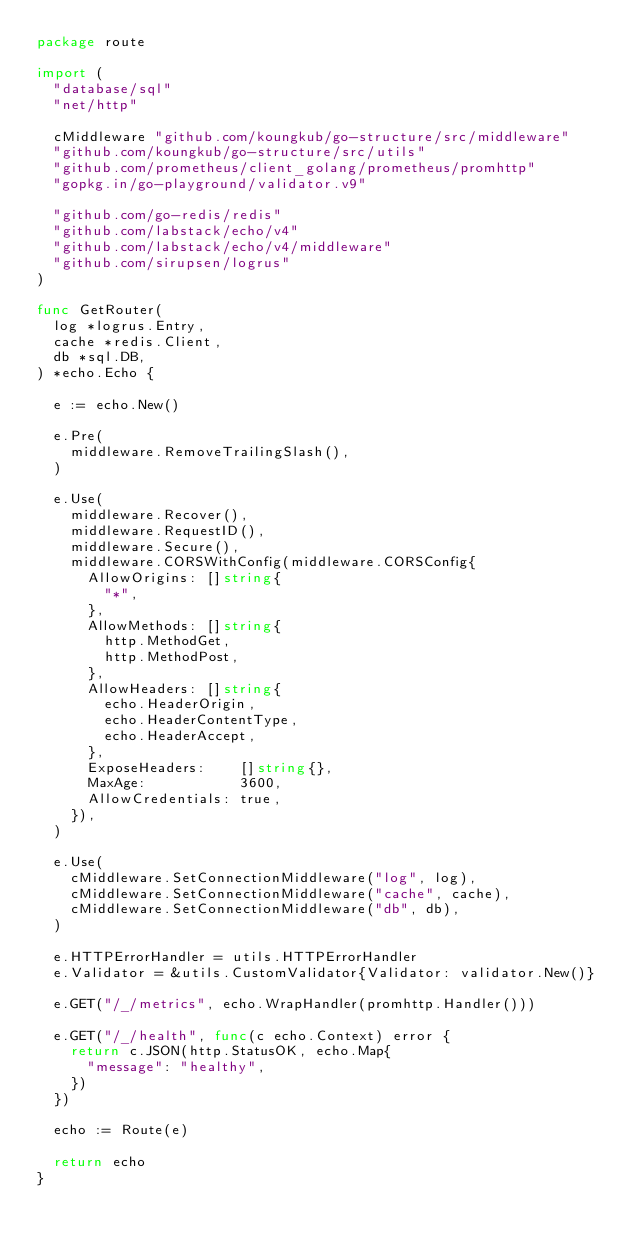Convert code to text. <code><loc_0><loc_0><loc_500><loc_500><_Go_>package route

import (
	"database/sql"
	"net/http"

	cMiddleware "github.com/koungkub/go-structure/src/middleware"
	"github.com/koungkub/go-structure/src/utils"
	"github.com/prometheus/client_golang/prometheus/promhttp"
	"gopkg.in/go-playground/validator.v9"

	"github.com/go-redis/redis"
	"github.com/labstack/echo/v4"
	"github.com/labstack/echo/v4/middleware"
	"github.com/sirupsen/logrus"
)

func GetRouter(
	log *logrus.Entry,
	cache *redis.Client,
	db *sql.DB,
) *echo.Echo {

	e := echo.New()

	e.Pre(
		middleware.RemoveTrailingSlash(),
	)

	e.Use(
		middleware.Recover(),
		middleware.RequestID(),
		middleware.Secure(),
		middleware.CORSWithConfig(middleware.CORSConfig{
			AllowOrigins: []string{
				"*",
			},
			AllowMethods: []string{
				http.MethodGet,
				http.MethodPost,
			},
			AllowHeaders: []string{
				echo.HeaderOrigin,
				echo.HeaderContentType,
				echo.HeaderAccept,
			},
			ExposeHeaders:    []string{},
			MaxAge:           3600,
			AllowCredentials: true,
		}),
	)

	e.Use(
		cMiddleware.SetConnectionMiddleware("log", log),
		cMiddleware.SetConnectionMiddleware("cache", cache),
		cMiddleware.SetConnectionMiddleware("db", db),
	)

	e.HTTPErrorHandler = utils.HTTPErrorHandler
	e.Validator = &utils.CustomValidator{Validator: validator.New()}

	e.GET("/_/metrics", echo.WrapHandler(promhttp.Handler()))

	e.GET("/_/health", func(c echo.Context) error {
		return c.JSON(http.StatusOK, echo.Map{
			"message": "healthy",
		})
	})

	echo := Route(e)

	return echo
}
</code> 